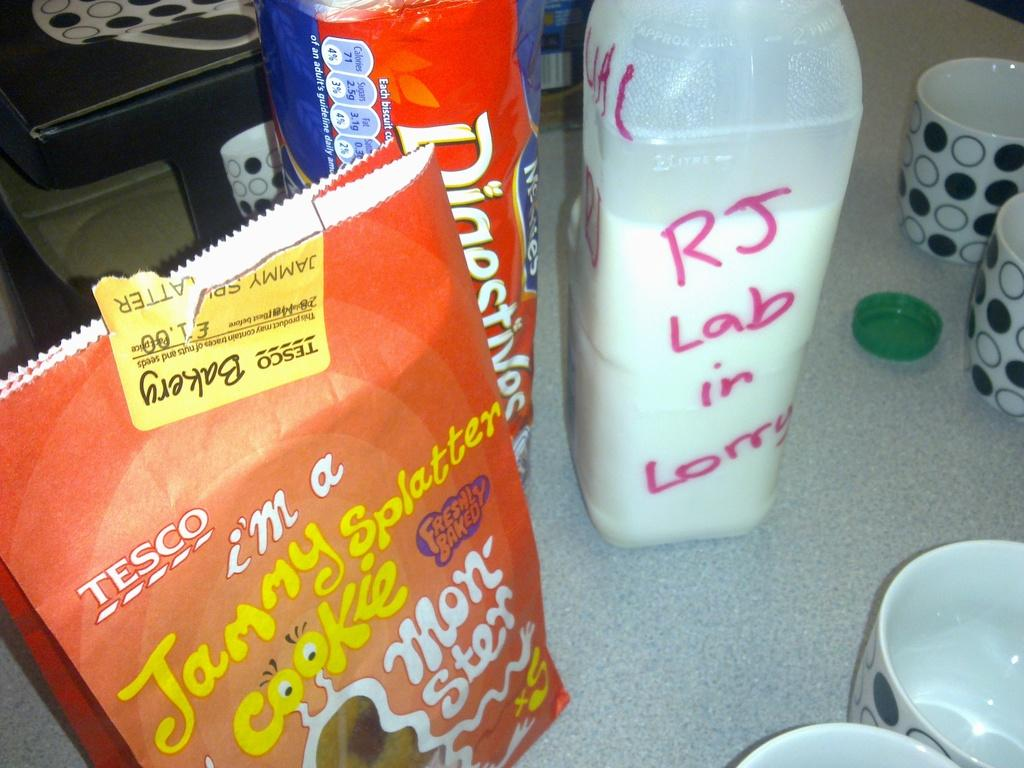<image>
Offer a succinct explanation of the picture presented. Orange bag which says TESCO on it next to some milk. 